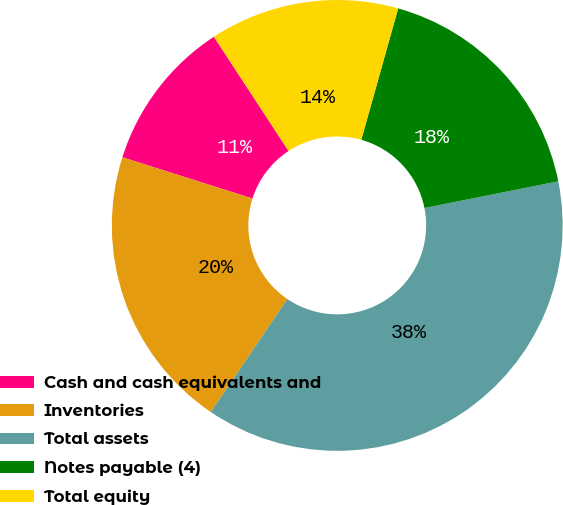<chart> <loc_0><loc_0><loc_500><loc_500><pie_chart><fcel>Cash and cash equivalents and<fcel>Inventories<fcel>Total assets<fcel>Notes payable (4)<fcel>Total equity<nl><fcel>10.9%<fcel>20.41%<fcel>37.61%<fcel>17.51%<fcel>13.57%<nl></chart> 